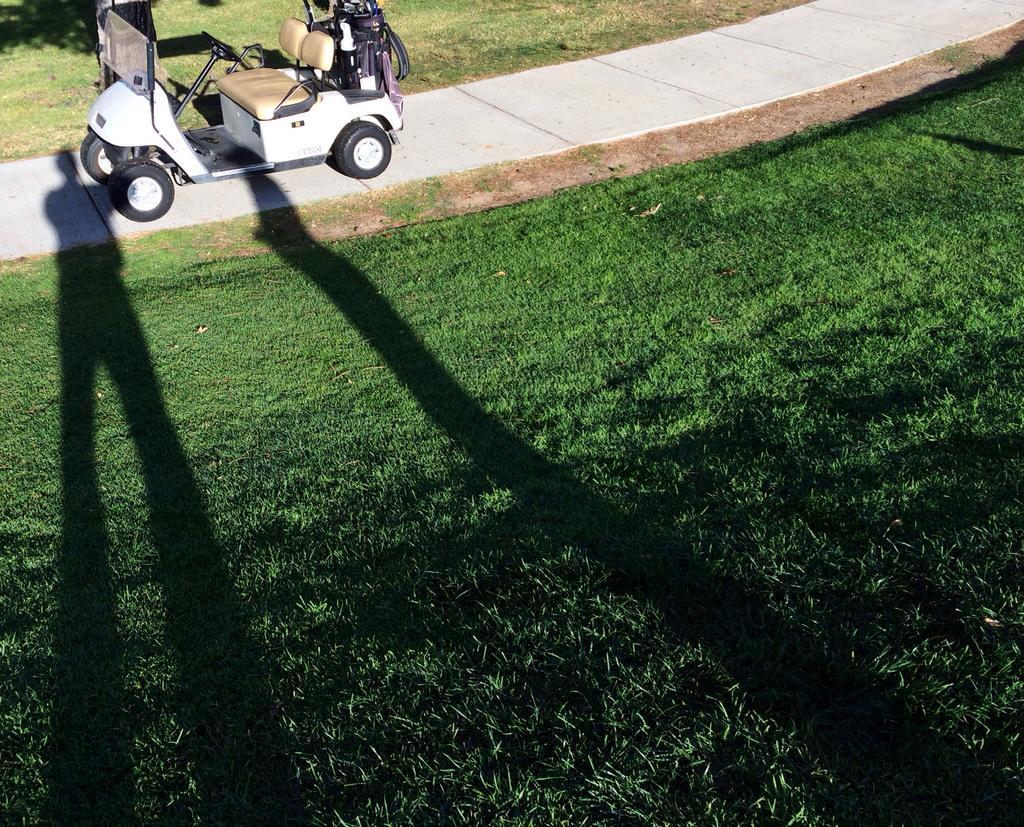In one or two sentences, can you explain what this image depicts? In this image, we can see grass and shadows. At the top of the image, we can see grass and vehicle on the walkway. 